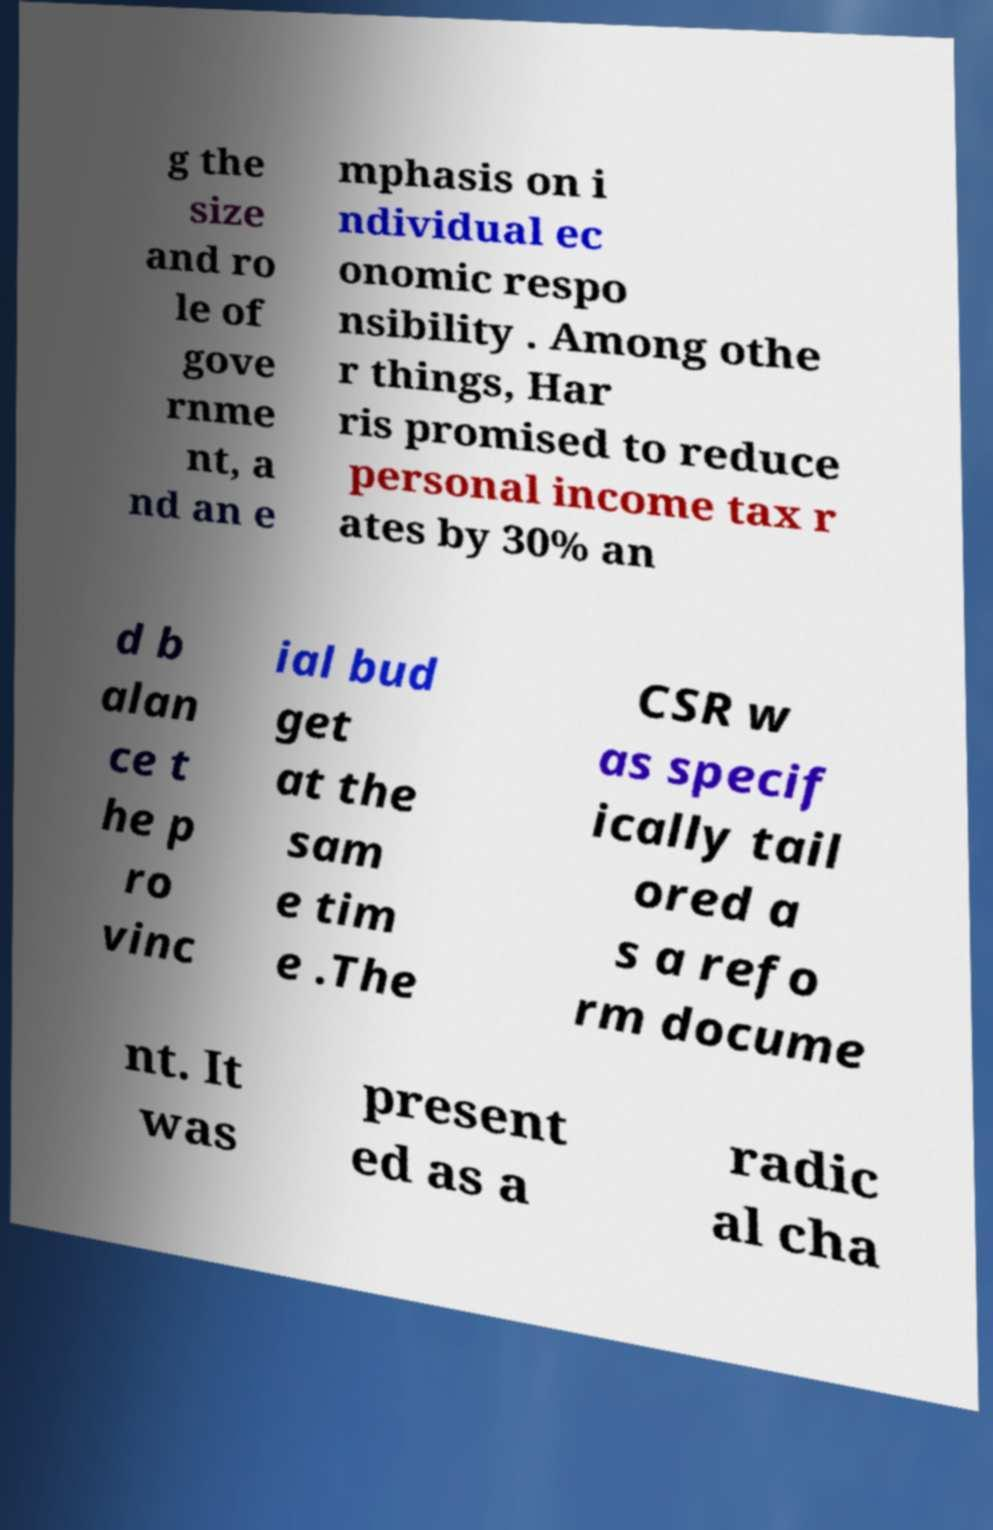Can you accurately transcribe the text from the provided image for me? g the size and ro le of gove rnme nt, a nd an e mphasis on i ndividual ec onomic respo nsibility . Among othe r things, Har ris promised to reduce personal income tax r ates by 30% an d b alan ce t he p ro vinc ial bud get at the sam e tim e .The CSR w as specif ically tail ored a s a refo rm docume nt. It was present ed as a radic al cha 